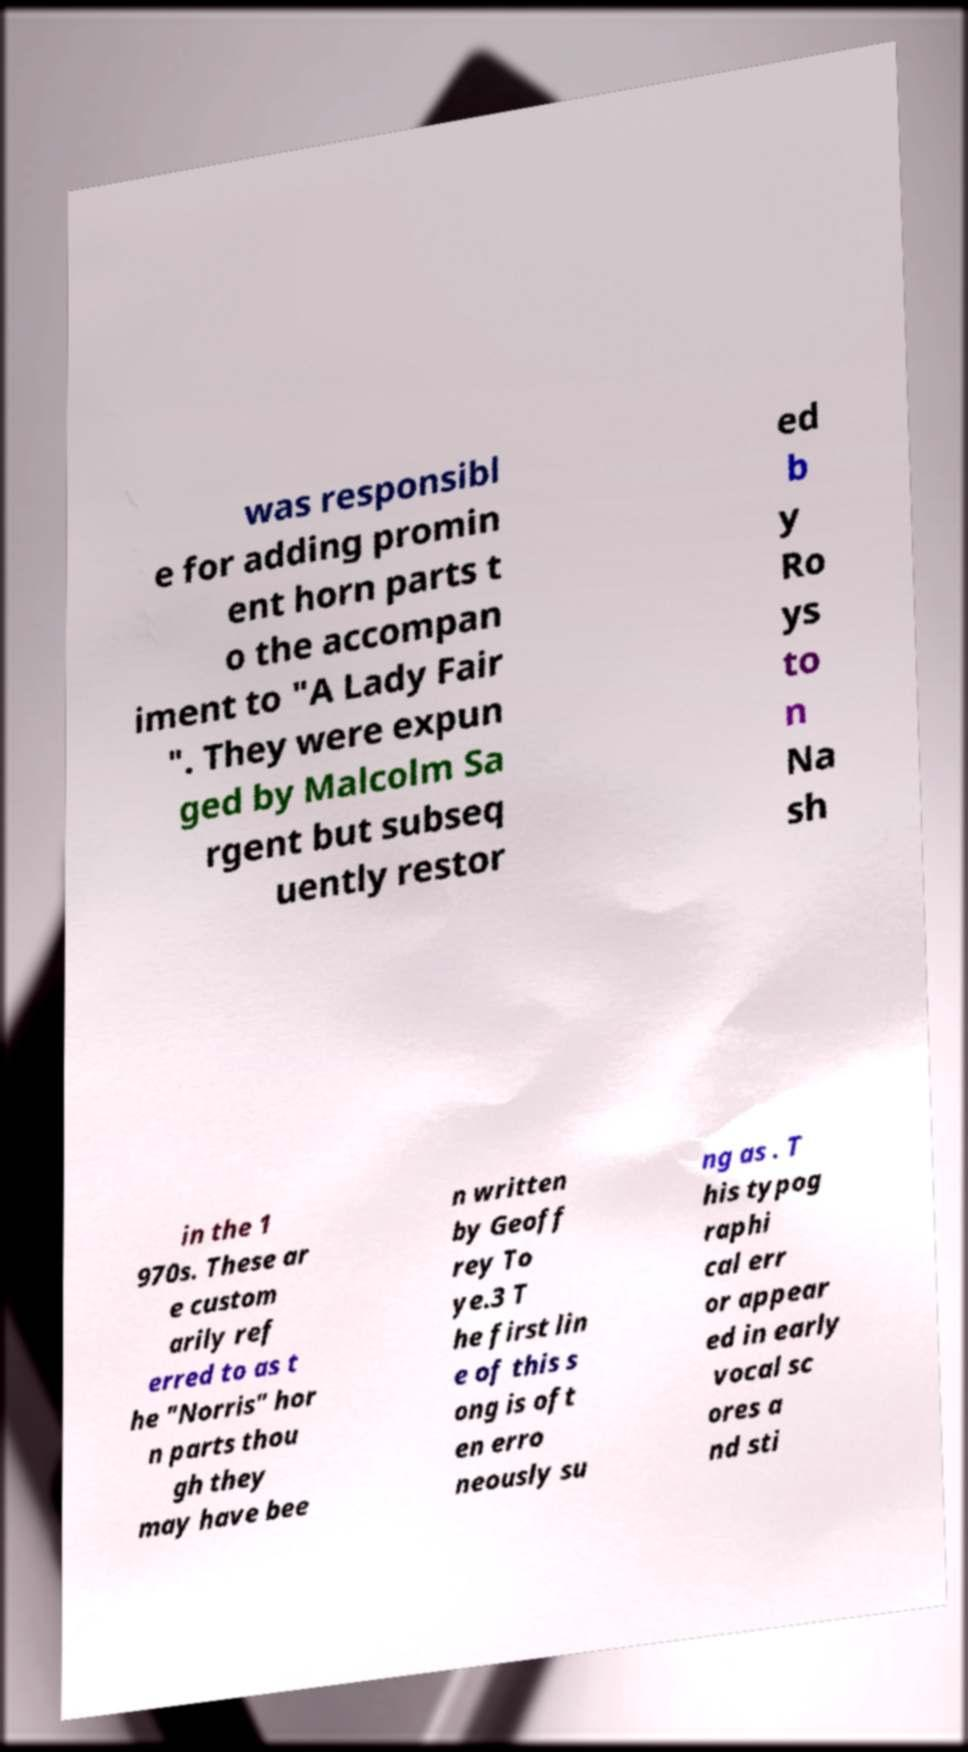For documentation purposes, I need the text within this image transcribed. Could you provide that? was responsibl e for adding promin ent horn parts t o the accompan iment to "A Lady Fair ". They were expun ged by Malcolm Sa rgent but subseq uently restor ed b y Ro ys to n Na sh in the 1 970s. These ar e custom arily ref erred to as t he "Norris" hor n parts thou gh they may have bee n written by Geoff rey To ye.3 T he first lin e of this s ong is oft en erro neously su ng as . T his typog raphi cal err or appear ed in early vocal sc ores a nd sti 